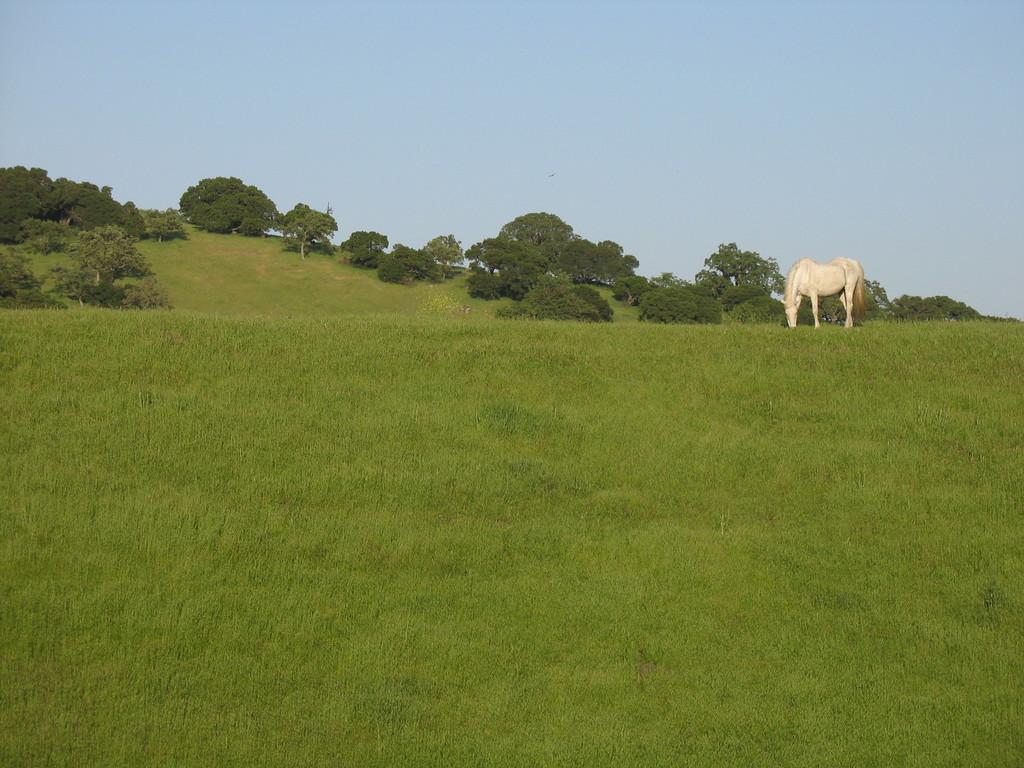What is the main setting of the image? There is an open grass ground in the image. What animal can be seen on the right side of the image? A white-colored horse is standing on the right side of the image. What type of vegetation is visible in the background of the image? There are trees in the background of the image. What part of the natural environment is visible in the background of the image? The sky is visible in the background of the image. What type of chess piece is the horse in the image? The image does not depict a chess piece; it shows a real horse standing on the grass ground. Can you hear any thunder in the image? The image is silent, and there is no indication of thunder or any sound. 